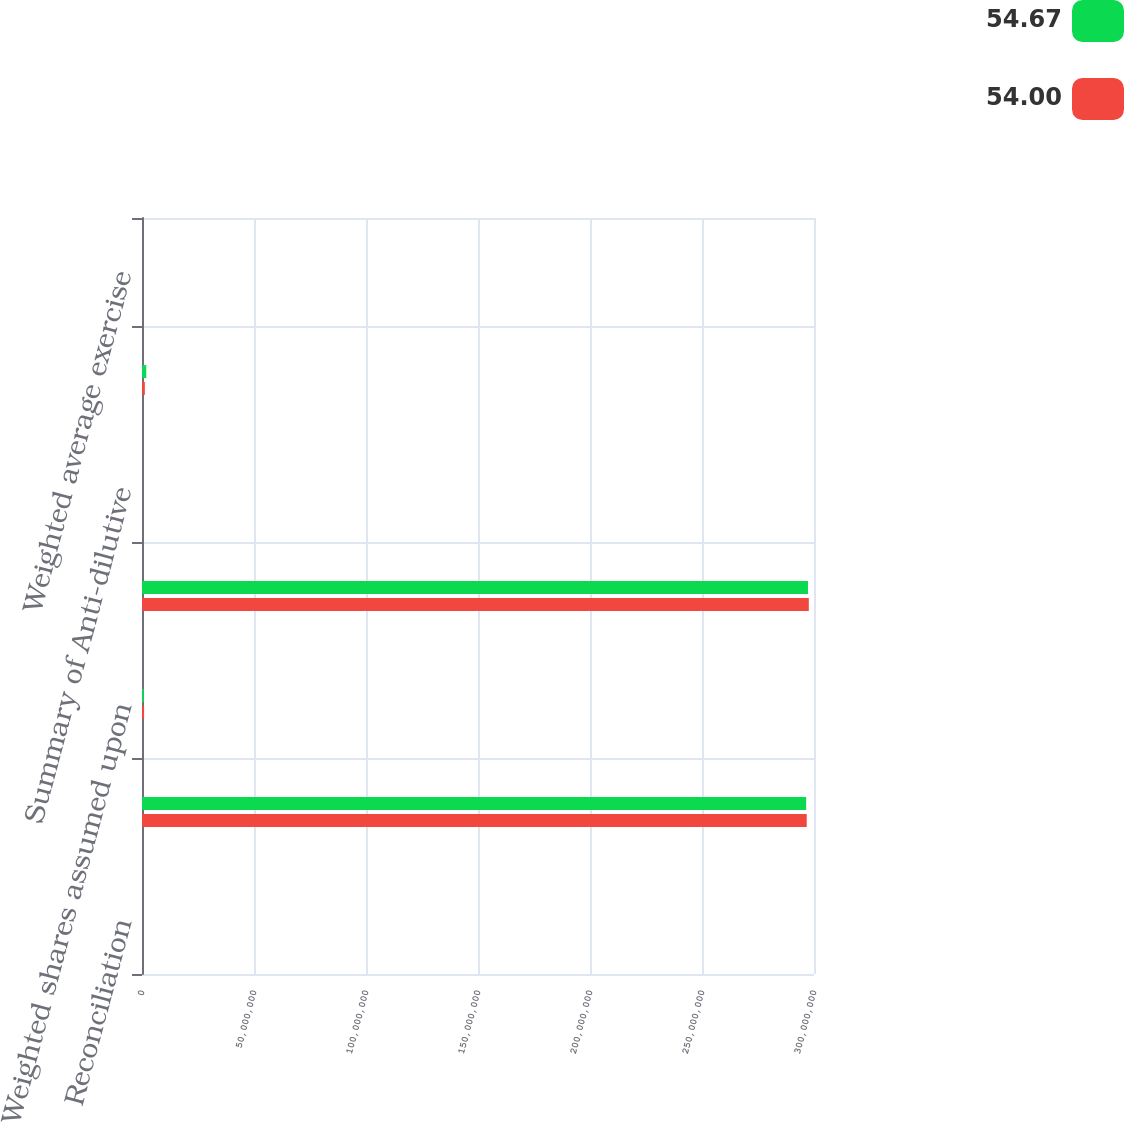Convert chart. <chart><loc_0><loc_0><loc_500><loc_500><stacked_bar_chart><ecel><fcel>Reconciliation<fcel>Basic weighted average shares<fcel>Weighted shares assumed upon<fcel>Diluted weighted average<fcel>Summary of Anti-dilutive<fcel>Options to purchase shares of<fcel>Weighted average exercise<nl><fcel>54.67<fcel>2014<fcel>2.9649e+08<fcel>822866<fcel>2.97313e+08<fcel>2014<fcel>1.90377e+06<fcel>54.67<nl><fcel>54<fcel>2013<fcel>2.96754e+08<fcel>929428<fcel>2.97684e+08<fcel>2013<fcel>1.27353e+06<fcel>54<nl></chart> 